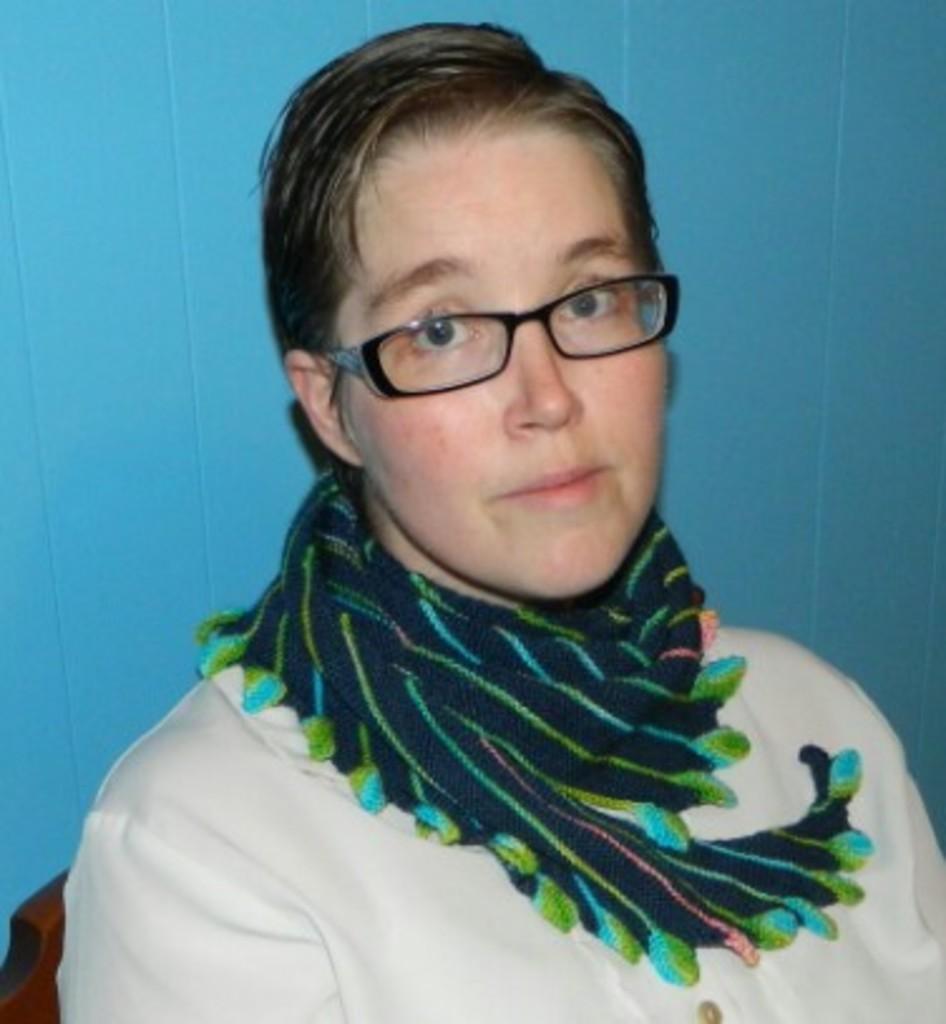Please provide a concise description of this image. This is a close up image of a woman wearing clothes, scarf, spectacles and the background is blue. 